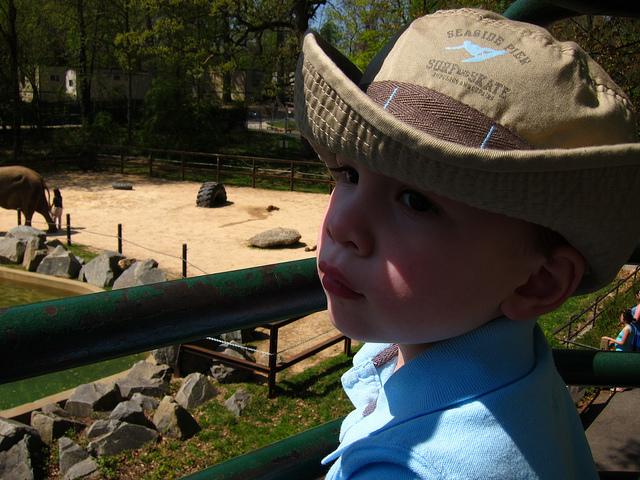Where are they?
Answer briefly. Zoo. Is that a male or female walking behind animal?
Concise answer only. Female. Is the person wearing a hat?
Write a very short answer. Yes. 